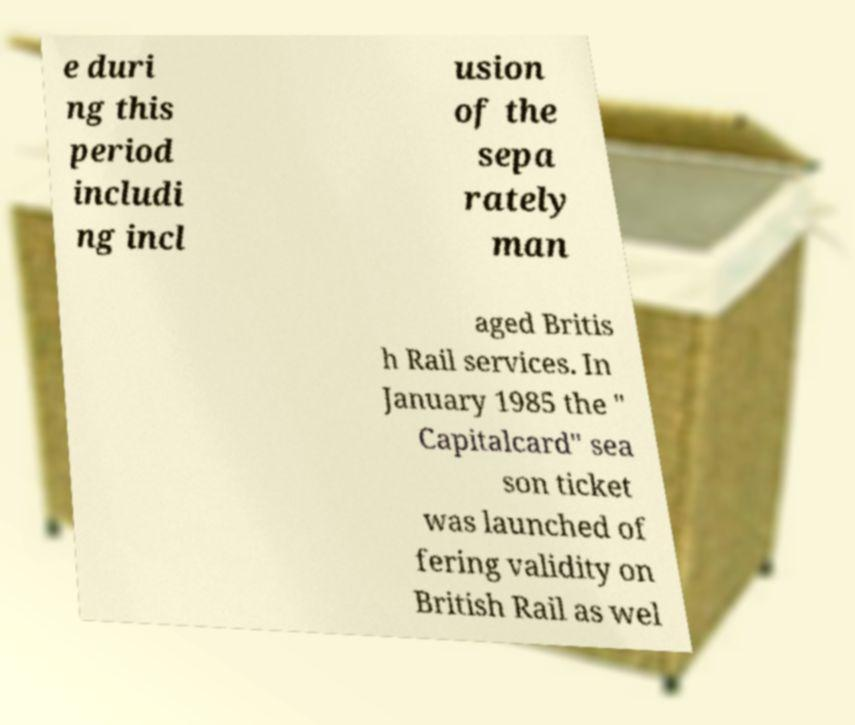Please identify and transcribe the text found in this image. e duri ng this period includi ng incl usion of the sepa rately man aged Britis h Rail services. In January 1985 the " Capitalcard" sea son ticket was launched of fering validity on British Rail as wel 